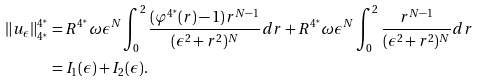<formula> <loc_0><loc_0><loc_500><loc_500>\| u _ { \epsilon } \| _ { 4 ^ { * } } ^ { 4 ^ { * } } & = R ^ { 4 ^ { * } } \omega \epsilon ^ { N } \int _ { 0 } ^ { 2 } \frac { ( \varphi ^ { 4 ^ { * } } ( r ) - 1 ) r ^ { N - 1 } } { ( \epsilon ^ { 2 } + r ^ { 2 } ) ^ { N } } d r + R ^ { 4 ^ { * } } \omega \epsilon ^ { N } \int _ { 0 } ^ { 2 } \frac { r ^ { N - 1 } } { ( \epsilon ^ { 2 } + r ^ { 2 } ) ^ { N } } d r \\ & = I _ { 1 } ( \epsilon ) + I _ { 2 } ( \epsilon ) . \\</formula> 